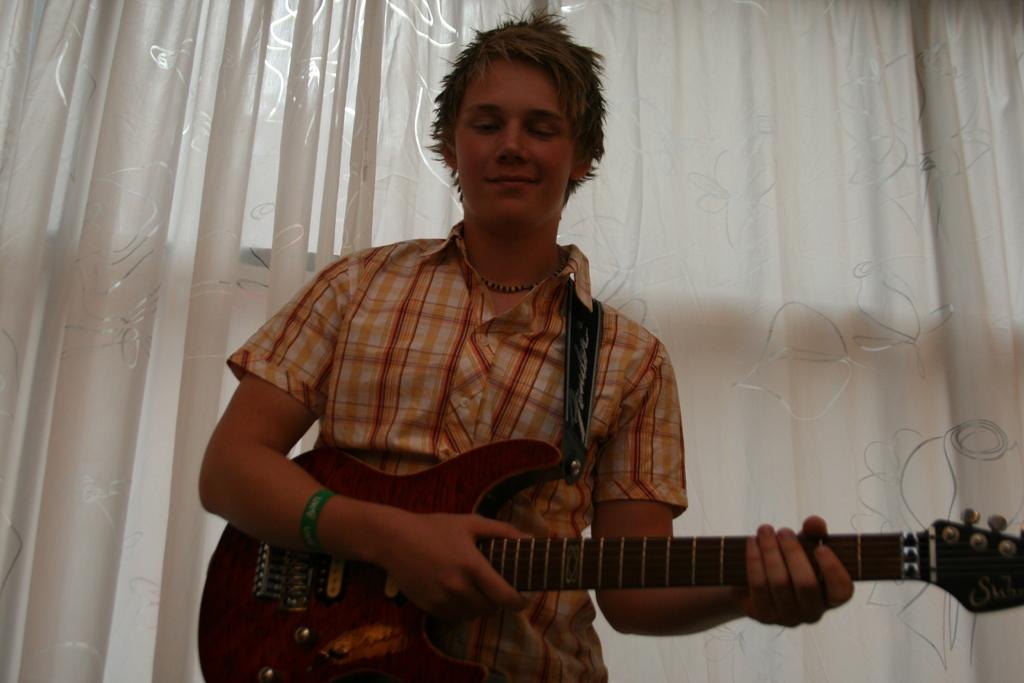What is the person in the image doing? The person is holding a guitar. What can be seen behind the person in the image? There are curtains visible behind the person. How many boats are visible in the image? There are no boats present in the image. What type of branch is the person sitting on in the image? There is no branch present in the image, and the person is not sitting on anything. 